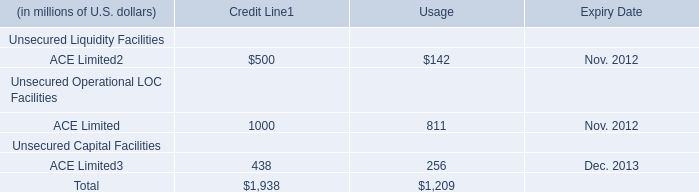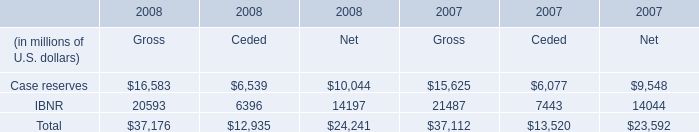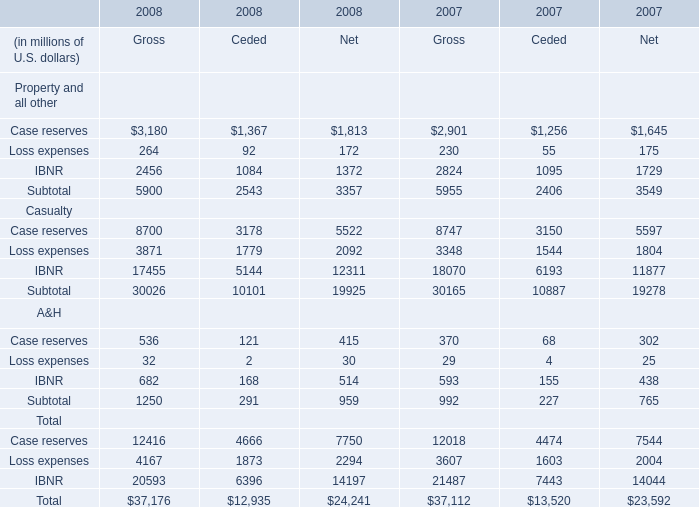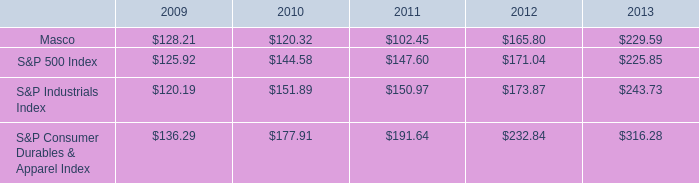Without Case reserves and Loss expenses, how much of A&H of Gross is there in total in 2008? (in million) 
Answer: 682. 